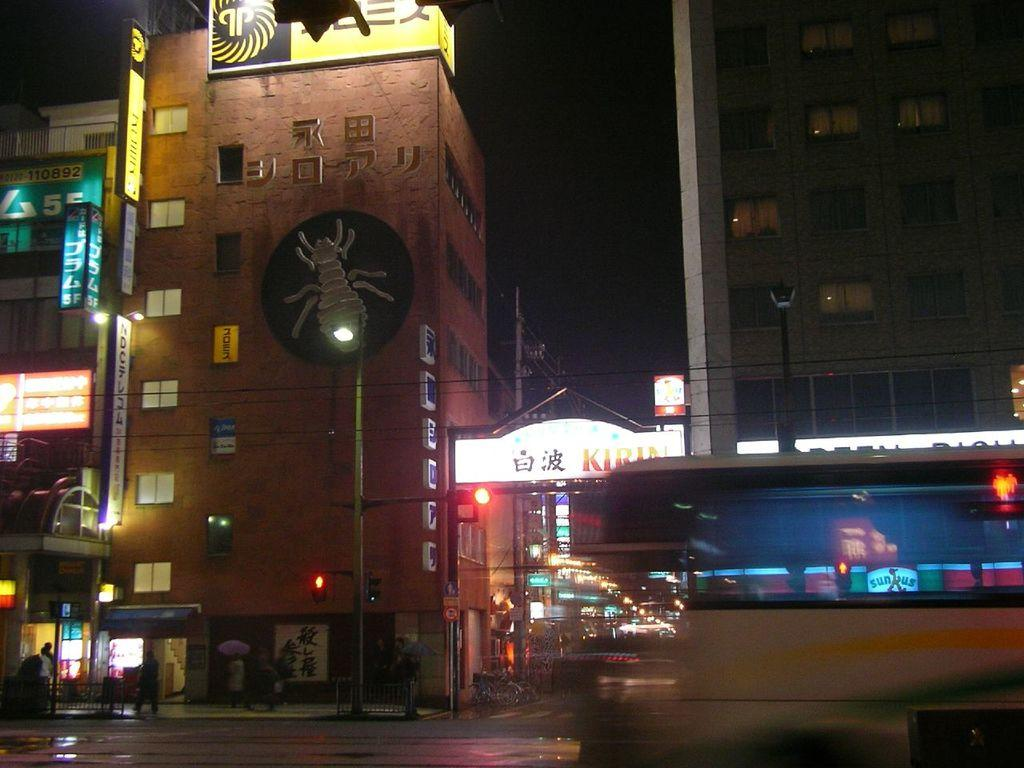What type of structures can be seen in the image? There are many buildings in the image. What type of lighting is present in the image? Street lights are present in the image. What type of signage is visible in the image? Posters are visible in the image. What type of text is present in the image? Text is present in the image. What type of weather phenomenon is visible in the image? Lightnings are visible in the image. What type of living organisms can be seen in the image? There are people in the image. What type of pathway is present in the image? A road is present in the image. What type of vehicle is visible in the image? There is a vehicle on the right side of the image. What type of sand can be seen on the sidewalk in the image? There is no sidewalk or sand present in the image. What type of impulse is being generated by the lightning in the image? The image does not provide information about the impulse generated by the lightning. 